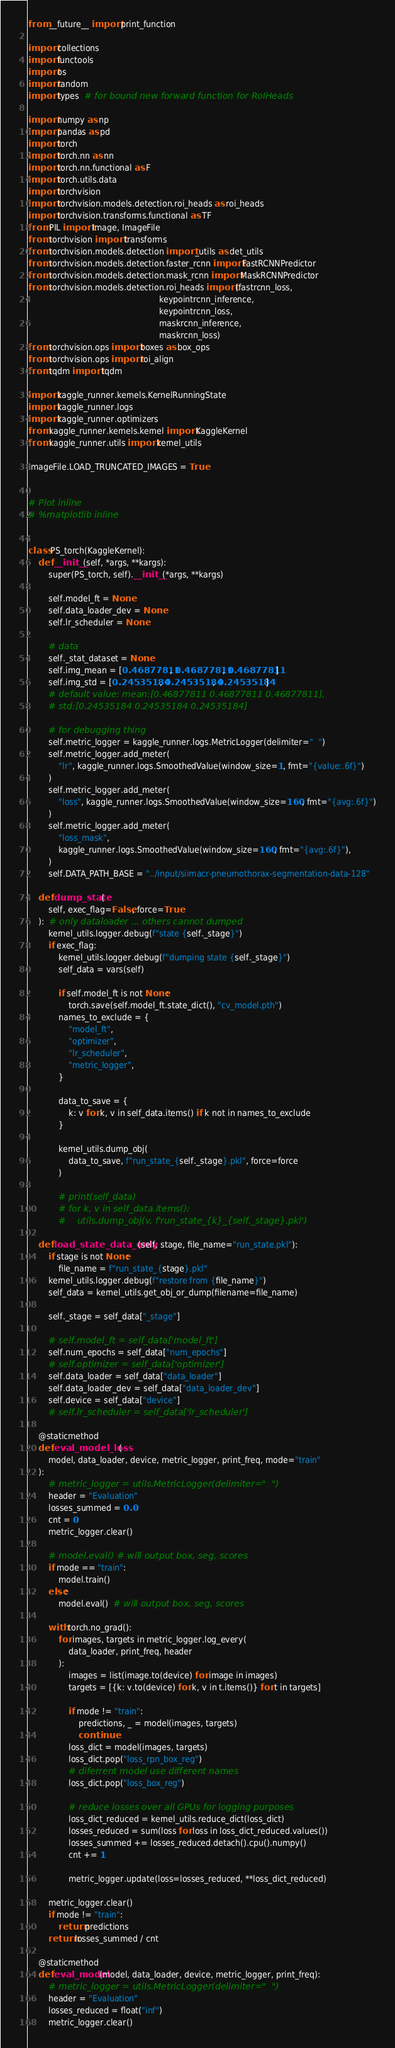<code> <loc_0><loc_0><loc_500><loc_500><_Python_>from __future__ import print_function

import collections
import functools
import os
import random
import types  # for bound new forward function for RoIHeads

import numpy as np
import pandas as pd
import torch
import torch.nn as nn
import torch.nn.functional as F
import torch.utils.data
import torchvision
import torchvision.models.detection.roi_heads as roi_heads
import torchvision.transforms.functional as TF
from PIL import Image, ImageFile
from torchvision import transforms
from torchvision.models.detection import _utils as det_utils
from torchvision.models.detection.faster_rcnn import FastRCNNPredictor
from torchvision.models.detection.mask_rcnn import MaskRCNNPredictor
from torchvision.models.detection.roi_heads import (fastrcnn_loss,
                                                    keypointrcnn_inference,
                                                    keypointrcnn_loss,
                                                    maskrcnn_inference,
                                                    maskrcnn_loss)
from torchvision.ops import boxes as box_ops
from torchvision.ops import roi_align
from tqdm import tqdm

import kaggle_runner.kernels.KernelRunningState
import kaggle_runner.logs
import kaggle_runner.optimizers
from kaggle_runner.kernels.kernel import KaggleKernel
from kaggle_runner.utils import kernel_utils

ImageFile.LOAD_TRUNCATED_IMAGES = True


# Plot inline
# %matplotlib inline


class PS_torch(KaggleKernel):
    def __init__(self, *args, **kargs):
        super(PS_torch, self).__init__(*args, **kargs)

        self.model_ft = None
        self.data_loader_dev = None
        self.lr_scheduler = None

        # data
        self._stat_dataset = None
        self.img_mean = [0.46877811, 0.46877811, 0.46877811]
        self.img_std = [0.24535184, 0.24535184, 0.24535184]
        # default value: mean:[0.46877811 0.46877811 0.46877811],
        # std:[0.24535184 0.24535184 0.24535184]

        # for debugging thing
        self.metric_logger = kaggle_runner.logs.MetricLogger(delimiter="  ")
        self.metric_logger.add_meter(
            "lr", kaggle_runner.logs.SmoothedValue(window_size=1, fmt="{value:.6f}")
        )
        self.metric_logger.add_meter(
            "loss", kaggle_runner.logs.SmoothedValue(window_size=160, fmt="{avg:.6f}")
        )
        self.metric_logger.add_meter(
            "loss_mask",
            kaggle_runner.logs.SmoothedValue(window_size=160, fmt="{avg:.6f}"),
        )
        self.DATA_PATH_BASE = "../input/siimacr-pneumothorax-segmentation-data-128"

    def dump_state(
        self, exec_flag=False, force=True
    ):  # only dataloader ... others cannot dumped
        kernel_utils.logger.debug(f"state {self._stage}")
        if exec_flag:
            kernel_utils.logger.debug(f"dumping state {self._stage}")
            self_data = vars(self)

            if self.model_ft is not None:
                torch.save(self.model_ft.state_dict(), "cv_model.pth")
            names_to_exclude = {
                "model_ft",
                "optimizer",
                "lr_scheduler",
                "metric_logger",
            }

            data_to_save = {
                k: v for k, v in self_data.items() if k not in names_to_exclude
            }

            kernel_utils.dump_obj(
                data_to_save, f"run_state_{self._stage}.pkl", force=force
            )

            # print(self_data)
            # for k, v in self_data.items():
            #    utils.dump_obj(v, f'run_state_{k}_{self._stage}.pkl')

    def load_state_data_only(self, stage, file_name="run_state.pkl"):
        if stage is not None:
            file_name = f"run_state_{stage}.pkl"
        kernel_utils.logger.debug(f"restore from {file_name}")
        self_data = kernel_utils.get_obj_or_dump(filename=file_name)

        self._stage = self_data["_stage"]

        # self.model_ft = self_data['model_ft']
        self.num_epochs = self_data["num_epochs"]
        # self.optimizer = self_data['optimizer']
        self.data_loader = self_data["data_loader"]
        self.data_loader_dev = self_data["data_loader_dev"]
        self.device = self_data["device"]
        # self.lr_scheduler = self_data['lr_scheduler']

    @staticmethod
    def eval_model_loss(
        model, data_loader, device, metric_logger, print_freq, mode="train"
    ):
        # metric_logger = utils.MetricLogger(delimiter="  ")
        header = "Evaluation"
        losses_summed = 0.0
        cnt = 0
        metric_logger.clear()

        # model.eval() # will output box, seg, scores
        if mode == "train":
            model.train()
        else:
            model.eval()  # will output box, seg, scores

        with torch.no_grad():
            for images, targets in metric_logger.log_every(
                data_loader, print_freq, header
            ):
                images = list(image.to(device) for image in images)
                targets = [{k: v.to(device) for k, v in t.items()} for t in targets]

                if mode != "train":
                    predictions, _ = model(images, targets)
                    continue
                loss_dict = model(images, targets)
                loss_dict.pop("loss_rpn_box_reg")
                # diferrent model use different names
                loss_dict.pop("loss_box_reg")

                # reduce losses over all GPUs for logging purposes
                loss_dict_reduced = kernel_utils.reduce_dict(loss_dict)
                losses_reduced = sum(loss for loss in loss_dict_reduced.values())
                losses_summed += losses_reduced.detach().cpu().numpy()
                cnt += 1

                metric_logger.update(loss=losses_reduced, **loss_dict_reduced)

        metric_logger.clear()
        if mode != "train":
            return predictions
        return losses_summed / cnt

    @staticmethod
    def eval_model(model, data_loader, device, metric_logger, print_freq):
        # metric_logger = utils.MetricLogger(delimiter="  ")
        header = "Evaluation"
        losses_reduced = float("inf")
        metric_logger.clear()
</code> 